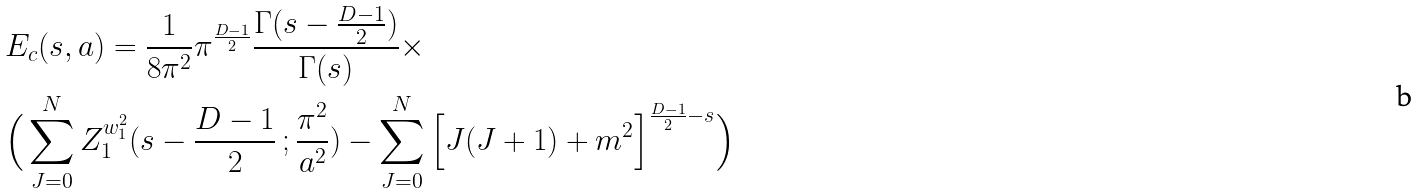<formula> <loc_0><loc_0><loc_500><loc_500>& E _ { c } ( s , a ) = \frac { 1 } { 8 \pi ^ { 2 } } \pi ^ { \frac { D - 1 } { 2 } } \frac { \Gamma ( s - \frac { D - 1 } { 2 } ) } { \Gamma ( s ) } \times \\ & \Big { ( } \sum _ { J = 0 } ^ { N } Z _ { 1 } ^ { w ^ { 2 } _ { 1 } } ( s - \frac { D - 1 } { 2 } { \, } ; \frac { \pi ^ { 2 } } { a ^ { 2 } } ) - \sum _ { J = 0 } ^ { N } \Big { [ } J ( J + 1 ) + m ^ { 2 } \Big { ] } ^ { \frac { D - 1 } { 2 } - s } \Big { ) }</formula> 